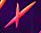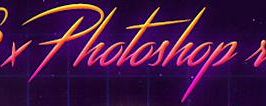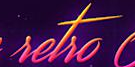Read the text content from these images in order, separated by a semicolon. ×; Photoshop; setso 